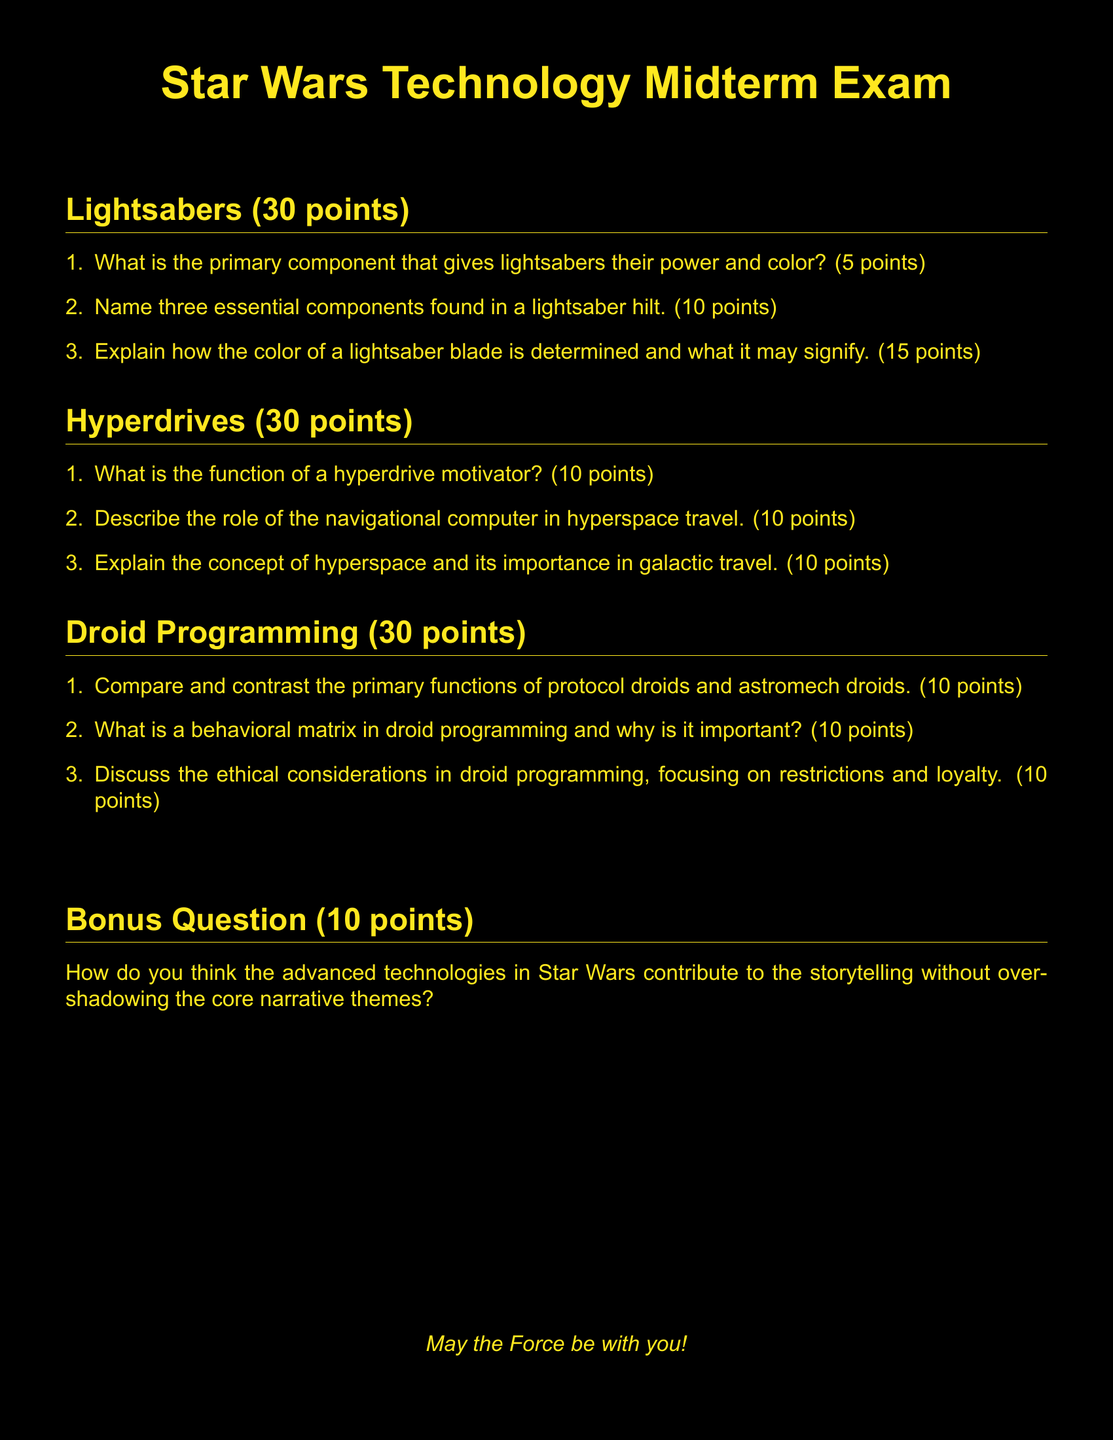What is the total point value for the Lightsabers section? The total point value for the Lightsabers section is the sum of the points for each question: 5 + 10 + 15 = 30 points.
Answer: 30 points What are the three main topics covered in the midterm exam? The three main topics covered in the midterm exam are Lightsabers, Hyperdrives, and Droid Programming.
Answer: Lightsabers, Hyperdrives, Droid Programming What is one essential component found in a lightsaber hilt? The document specifies that there are three essential components in a lightsaber hilt, and one example is needed.
Answer: Crystal How many points is the bonus question worth? The bonus question has a defined point value listed in the document.
Answer: 10 points What does a behavioral matrix pertain to? The behavioral matrix is a key aspect in the context of droid programming as described in the document.
Answer: Droid programming What is the importance of hyperspace in the Star Wars universe? The document mentions hyperspace's significance in intergalactic travel.
Answer: Galactic travel How many points can be earned from the Droid Programming section? The total points possible from the Droid Programming section are indicated in the document.
Answer: 30 points What is the first question in the Hyperdrives section about? The first question in the Hyperdrives section specifically addresses the function of a hyperdrive motivator.
Answer: Function of a hyperdrive motivator What color is used for the text in the Star Wars Technology Midterm Exam? The document specifies a specific color for the text.
Answer: Yellow 